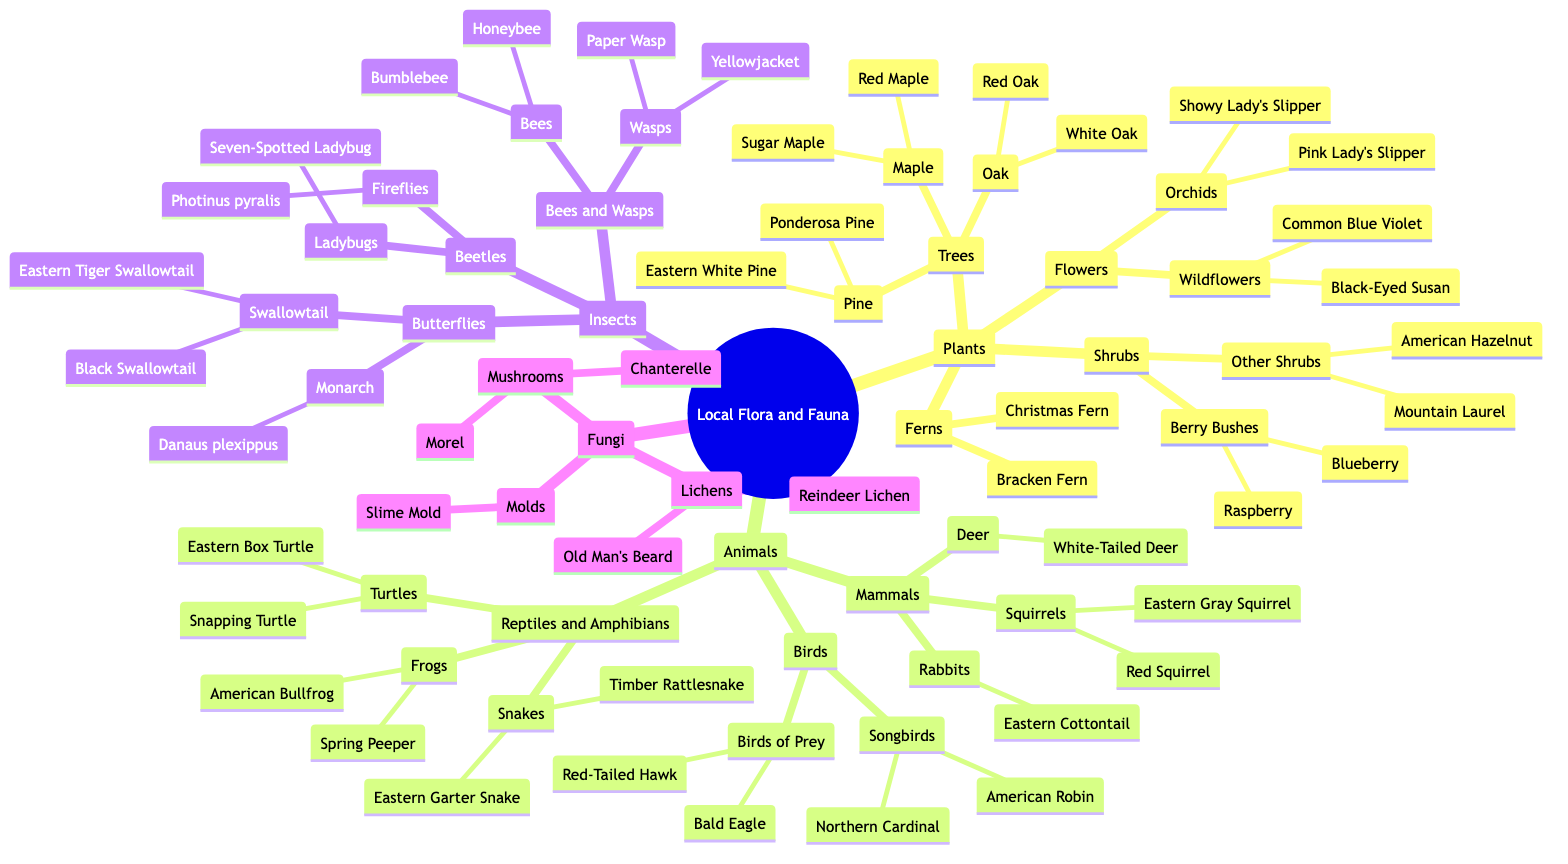What are the two types of trees listed under Plants? The diagram shows that under the category of Plants, there are Trees, which are further divided into Oak and Maple.
Answer: Oak and Maple How many types of birds are identified in the diagram? The diagram categorizes Birds into two types: Songbirds and Birds of Prey. Thus, there are a total of 2 types of birds.
Answer: 2 types Which mammal is a type of rabbit mentioned in the diagram? Under the category of Mammals, the diagram indicates that Eastern Cottontail is a type of rabbit.
Answer: Eastern Cottontail How many types of mushrooms are listed under Fungi? The Fungi section categorizes Mushrooms into 2 distinct types: Morel and Chanterelle, so there are a total of 2 types of mushrooms.
Answer: 2 What is the relationship between Bees and Wasps in the Insects category? In the diagram, Bees and Wasps are grouped together under the Insects category, indicating that they are subcategories of insects.
Answer: Subcategories of insects Which types of flowers are categorized under Wildflowers? The diagram specifies that under Flowers, Wildflowers include Black-Eyed Susan and Common Blue Violet.
Answer: Black-Eyed Susan and Common Blue Violet How many species of turtles are mentioned? The Reptiles and Amphibians section specifies that there are 2 species of turtles: Eastern Box Turtle and Snapping Turtle.
Answer: 2 species Which type of fern is listed in the diagram? The Ferns section of the diagram only includes 2 types: Bracken Fern and Christmas Fern, so either can be considered as listed.
Answer: Bracken Fern or Christmas Fern What distinguishes the Monarch butterfly from the Swallowtail butterflies in the diagram? The diagram categorizes butterflies into two distinct groups: Swallowtail (which includes Eastern Tiger Swallowtail and Black Swallowtail) and Monarch (which specifically refers to Danaus plexippus), indicating a separation of these groups.
Answer: Separation of groups 